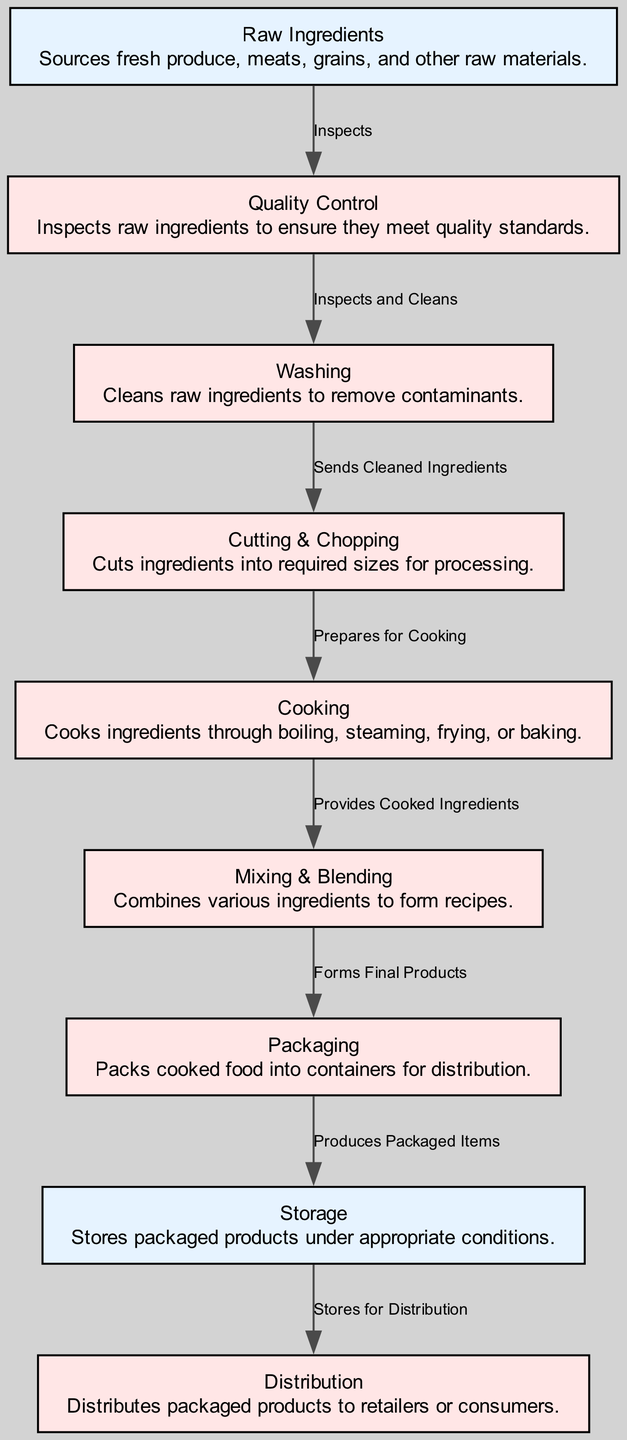What is the first node in the food processing pipeline? The first node is "Raw Ingredients". It is explicitly indicated as the starting point in the flow of the diagram, which shows the order of processes.
Answer: Raw Ingredients How many process nodes are there in the diagram? Counting the nodes categorized as "Process", we identify that there are seven processes listed: Quality Control, Washing, Cutting & Chopping, Cooking, Mixing & Blending, Packaging, and Distribution. Thus, the total is seven process nodes.
Answer: Seven What is the responsibility of the mixing node? The "Mixing & Blending" node is responsible for combining various ingredients to form recipes, which is explicitly stated in its details in the diagram.
Answer: Combines various ingredients to form recipes Which node sends cleaned ingredients to the cutting node? The "Washing" node sends cleaned ingredients to the "Cutting & Chopping" node. This relationship is indicated by the directional edge labeled "Sends Cleaned Ingredients" in the diagram.
Answer: Washing What is the relationship between the cooking and mixing nodes? The cooking node provides cooked ingredients to the mixing node. This is shown in the diagram by the edge connecting the two nodes, indicating the flow of information regarding ingredient preparation.
Answer: Provides Cooked Ingredients Which node stores packaged products under appropriate conditions? The "Storage" node is responsible for storing packaged products. The diagram defines its role clearly and places it directly after the packaging process, emphasizing its responsibility.
Answer: Storage How does the quality control node relate to the raw ingredients? The quality control node inspects the raw ingredients, as shown by the edge labeled "Inspects" connecting "Raw Ingredients" to "Quality Control". This establishes the primary role of quality assurance at the initial stage of the pipeline.
Answer: Inspects What are the final products produced by the packaging node? The "Packaging" node produces packaged items. This is articulated in the diagram, indicating the transition from the packaging process to the storage node, showing the output of the packaging activity.
Answer: Packaged Items What is the last step in the food processing pipeline? The last step in the food processing pipeline is the "Distribution" node, which indicates the final stage where packaged products are sent out to retailers or consumers after being stored.
Answer: Distribution 